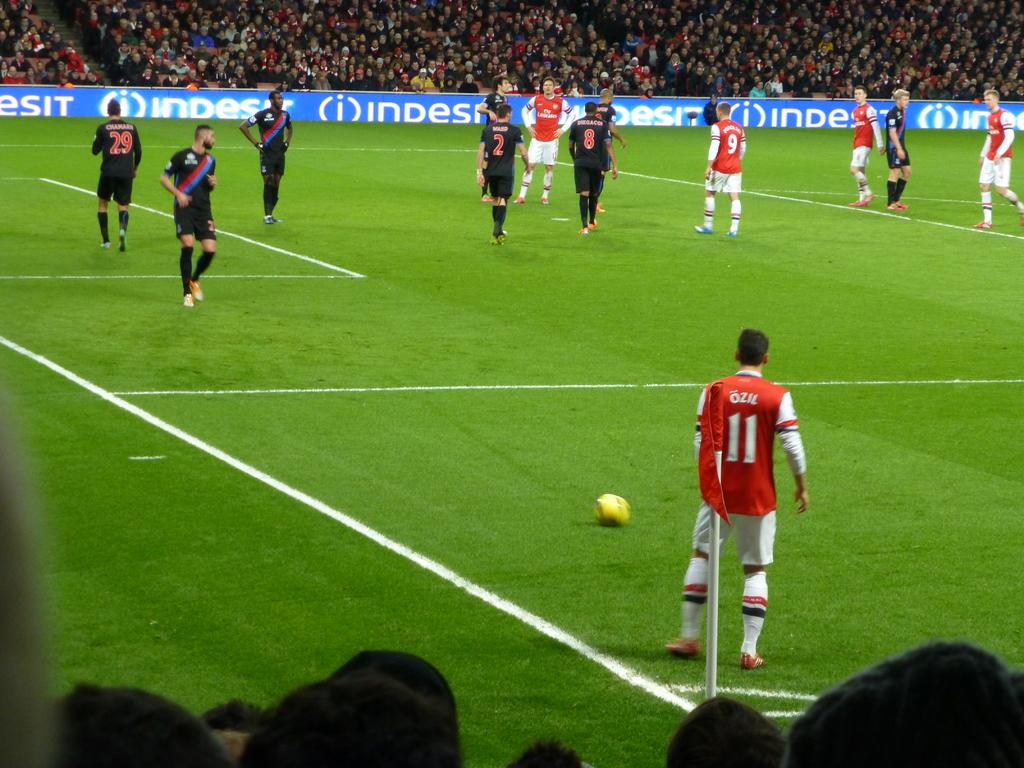What is one of the sponsors advertised in this stadium?
Offer a terse response. Indesit. 